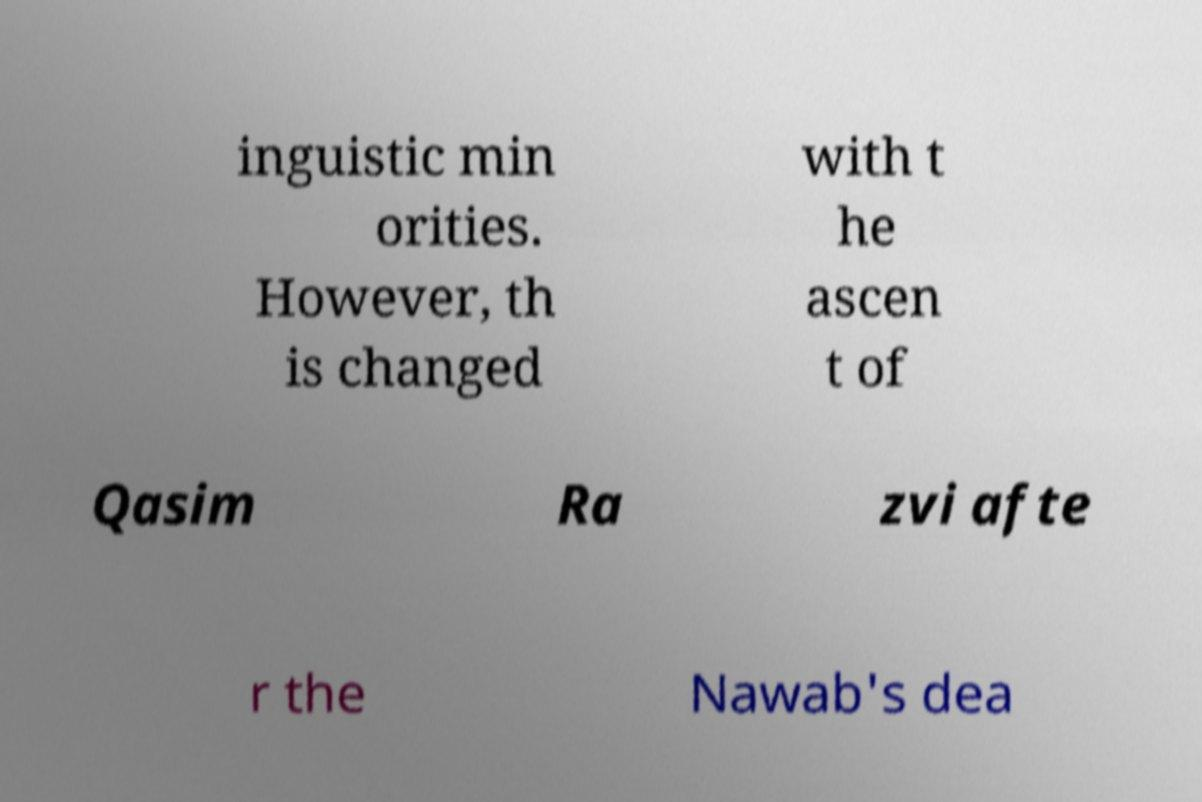For documentation purposes, I need the text within this image transcribed. Could you provide that? inguistic min orities. However, th is changed with t he ascen t of Qasim Ra zvi afte r the Nawab's dea 